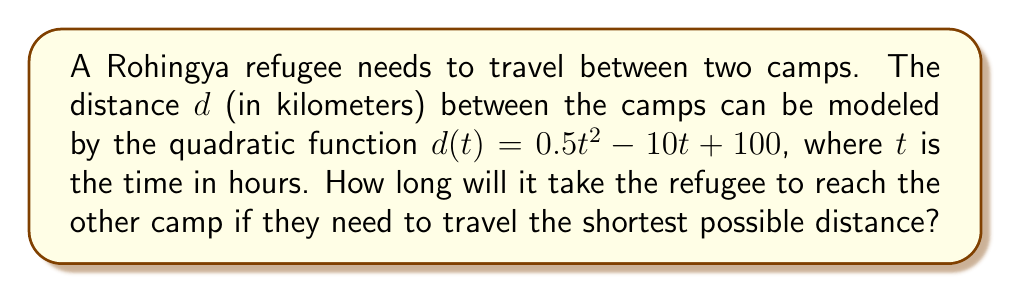Can you solve this math problem? To find the shortest possible distance and the corresponding time, we need to follow these steps:

1) The quadratic function $d(t) = 0.5t^2 - 10t + 100$ represents a parabola. The shortest distance occurs at the vertex of this parabola.

2) For a quadratic function in the form $f(t) = at^2 + bt + c$, the t-coordinate of the vertex is given by $t = -\frac{b}{2a}$.

3) In our case, $a = 0.5$ and $b = -10$. Let's substitute these values:

   $t = -\frac{(-10)}{2(0.5)} = \frac{10}{1} = 10$

4) Therefore, the shortest distance occurs when $t = 10$ hours.

5) To verify, we can calculate the distance at $t = 9$, $t = 10$, and $t = 11$:

   $d(9) = 0.5(9^2) - 10(9) + 100 = 40.5 + (-90) + 100 = 50.5$ km
   $d(10) = 0.5(10^2) - 10(10) + 100 = 50 + (-100) + 100 = 50$ km
   $d(11) = 0.5(11^2) - 10(11) + 100 = 60.5 + (-110) + 100 = 50.5$ km

   This confirms that the shortest distance is at $t = 10$ hours.
Answer: 10 hours 